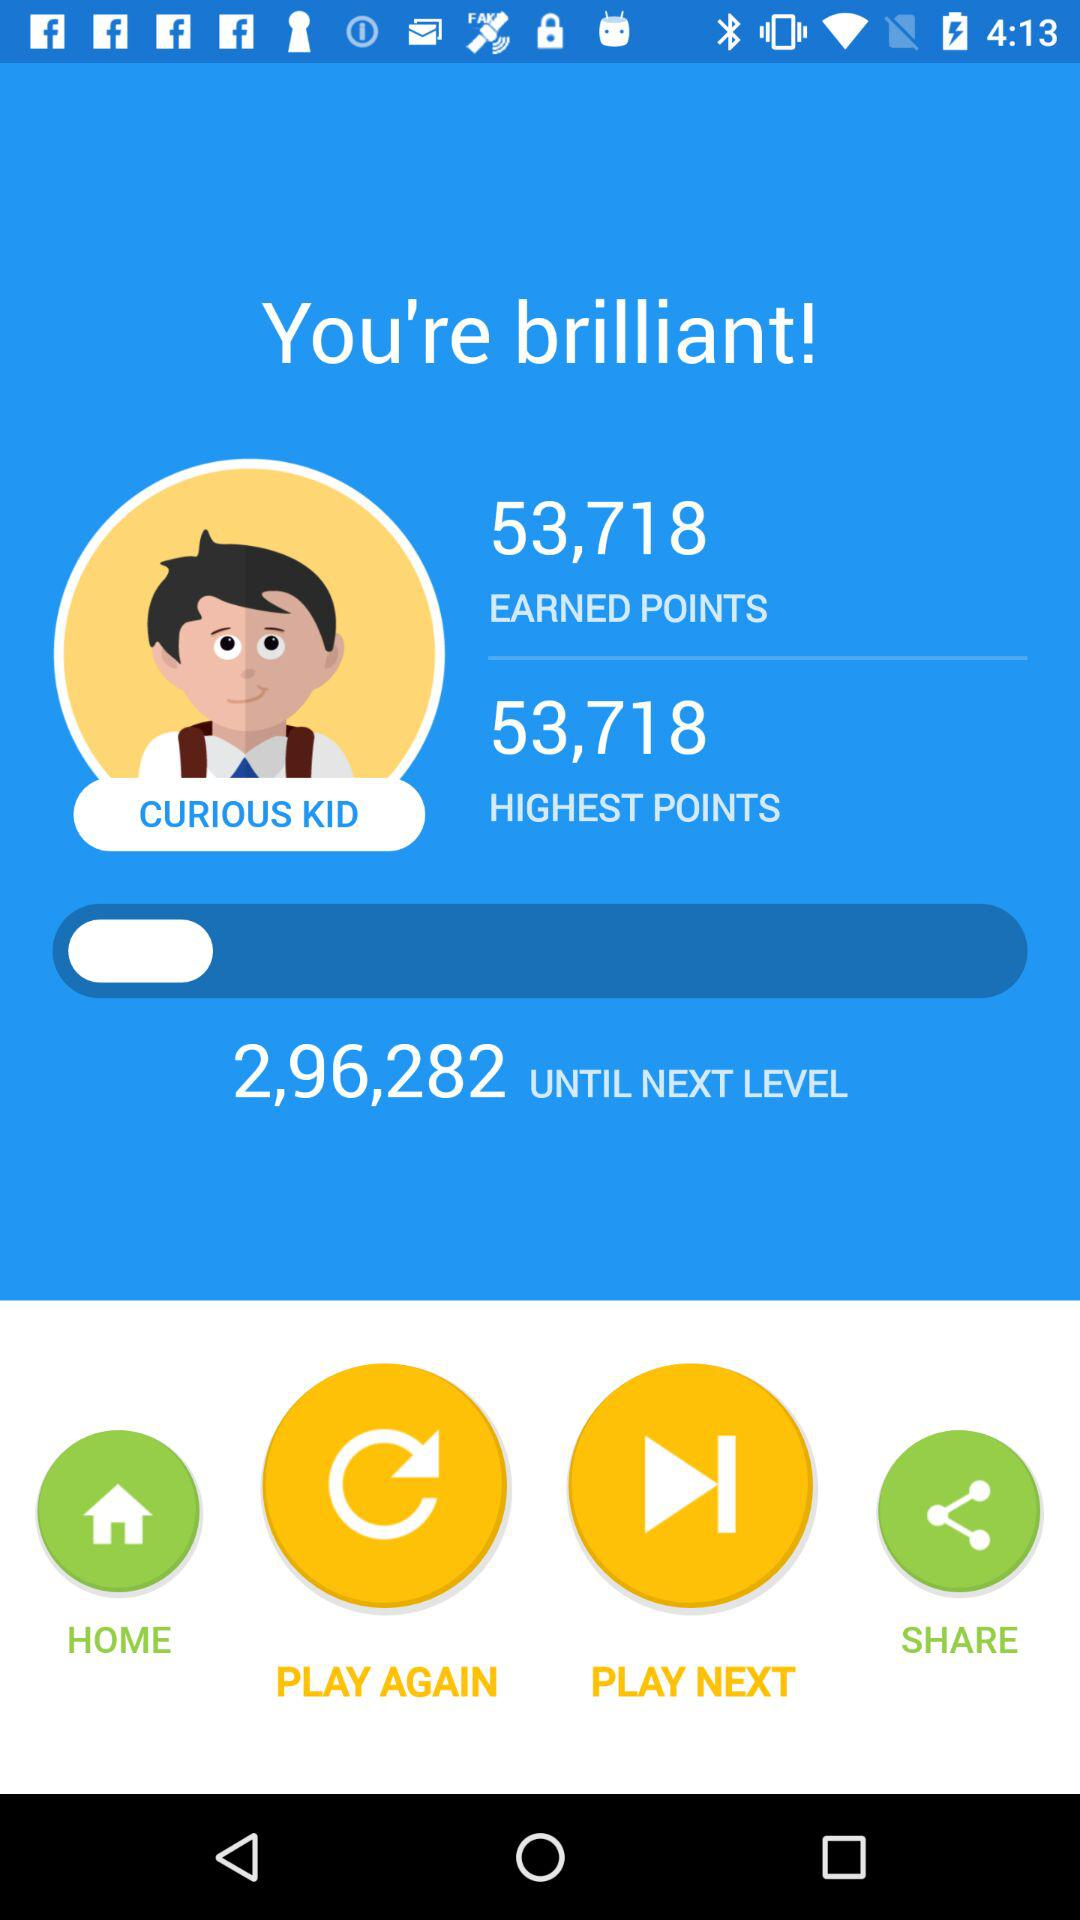How many points have been earned? There are 53,718 points that have been earned. 